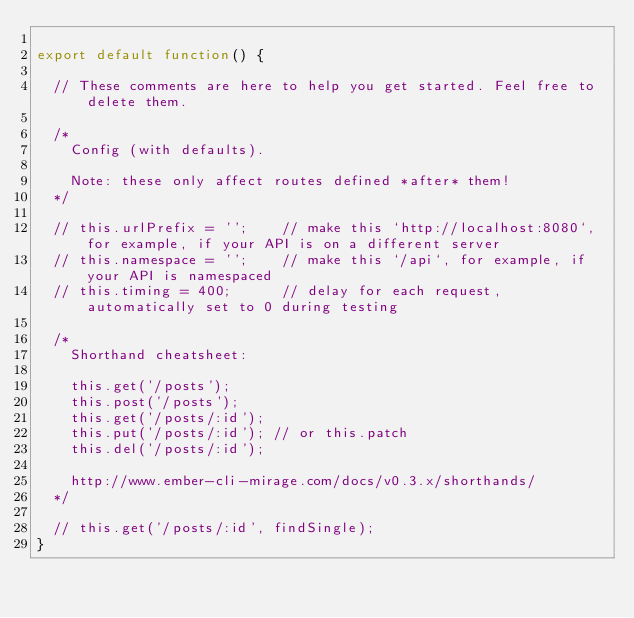Convert code to text. <code><loc_0><loc_0><loc_500><loc_500><_JavaScript_>
export default function() {

  // These comments are here to help you get started. Feel free to delete them.

  /*
    Config (with defaults).

    Note: these only affect routes defined *after* them!
  */

  // this.urlPrefix = '';    // make this `http://localhost:8080`, for example, if your API is on a different server
  // this.namespace = '';    // make this `/api`, for example, if your API is namespaced
  // this.timing = 400;      // delay for each request, automatically set to 0 during testing

  /*
    Shorthand cheatsheet:

    this.get('/posts');
    this.post('/posts');
    this.get('/posts/:id');
    this.put('/posts/:id'); // or this.patch
    this.del('/posts/:id');

    http://www.ember-cli-mirage.com/docs/v0.3.x/shorthands/
  */

  // this.get('/posts/:id', findSingle);
}
</code> 